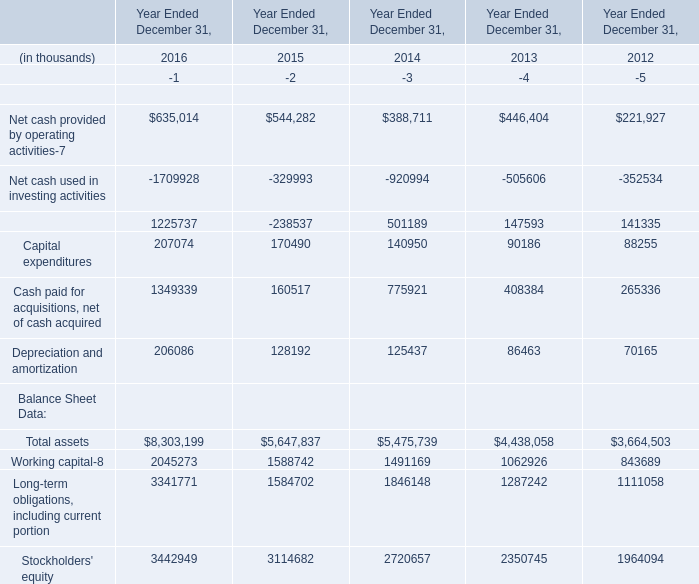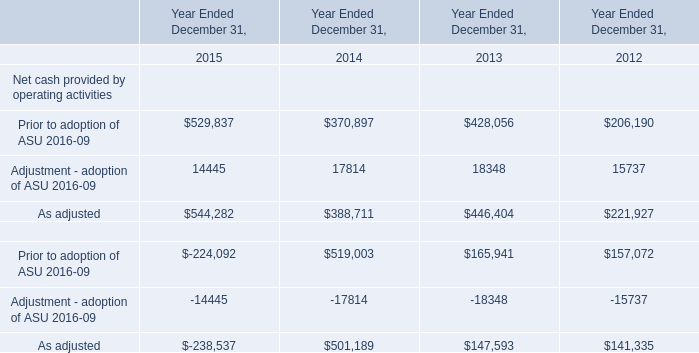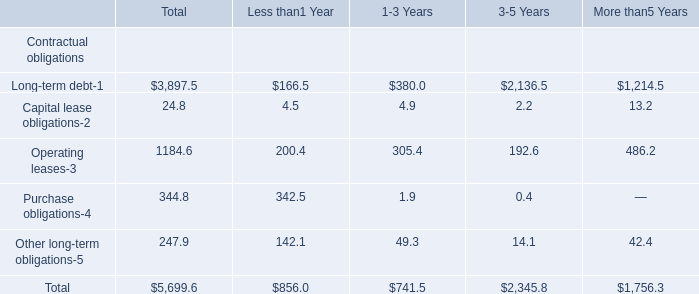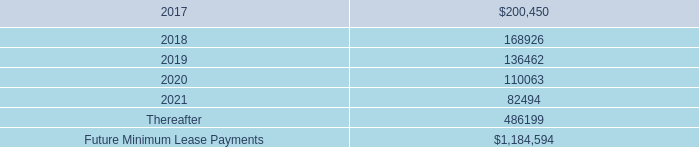what was the percentage change in rental expense for operating leases from 2015 to 2016? 
Computations: ((211.5 - 168.4) / 168.4)
Answer: 0.25594. 